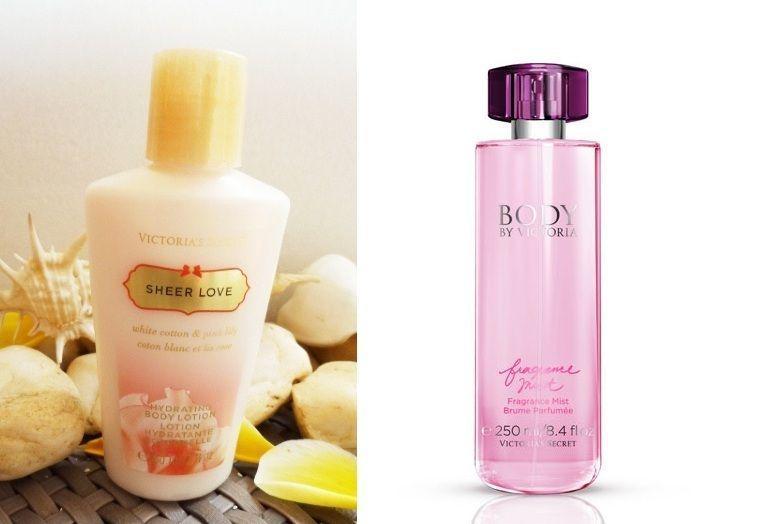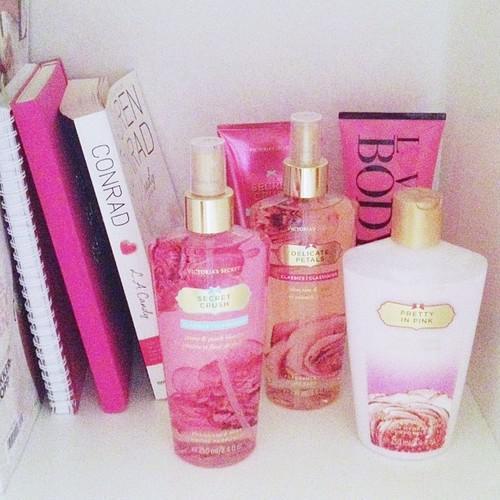The first image is the image on the left, the second image is the image on the right. Assess this claim about the two images: "The bottles in the left image are arranged on a white cloth background.". Correct or not? Answer yes or no. No. The first image is the image on the left, the second image is the image on the right. Analyze the images presented: Is the assertion "More beauty products are pictured in the left image than in the right image." valid? Answer yes or no. No. 